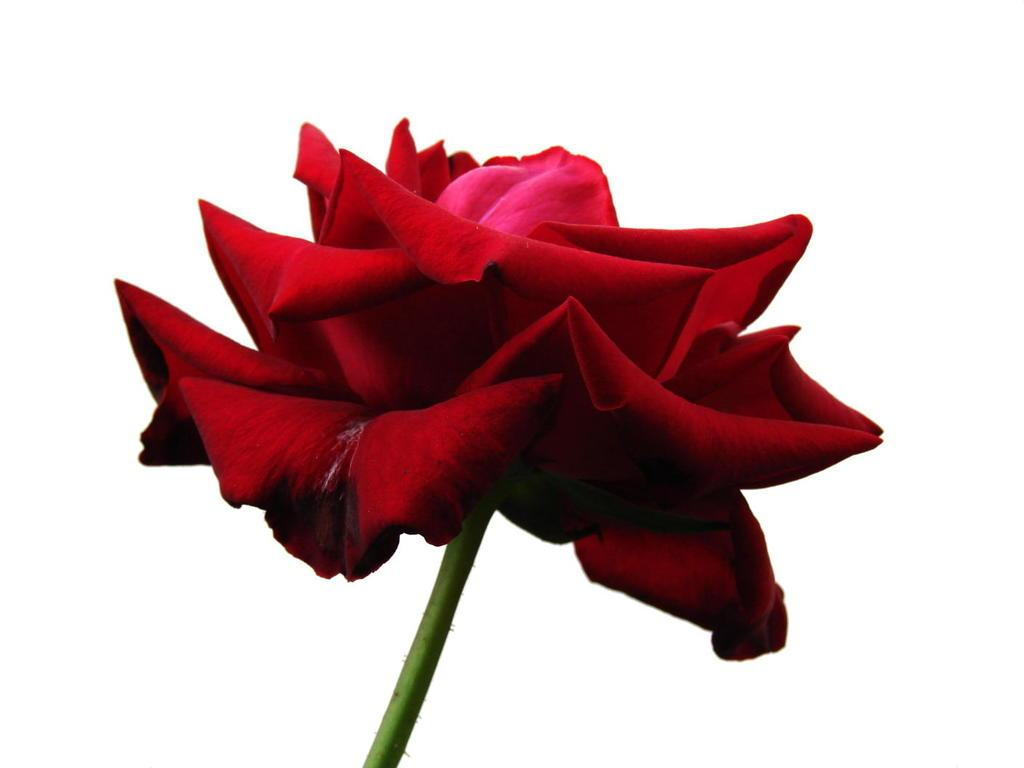What type of flower is in the image? There is a rose flower in the image. What color is the rose flower? The rose flower is red in color. Does the rose flower have any visible parts besides the petals? Yes, the rose flower has a stem. What is the price of the wren perched on the rose flower in the image? There is no wren present in the image, and therefore no price can be determined. 